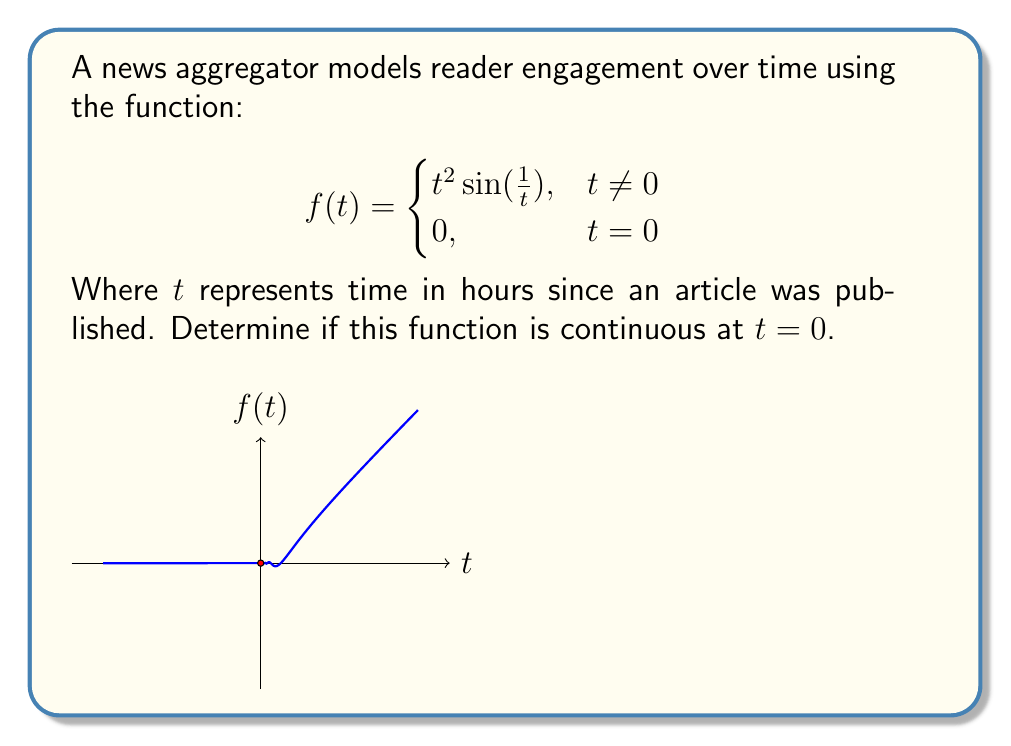Give your solution to this math problem. To determine if the function is continuous at $t = 0$, we need to check three conditions:

1. $f(0)$ exists
2. $\lim_{t \to 0} f(t)$ exists
3. $\lim_{t \to 0} f(t) = f(0)$

Step 1: Check if $f(0)$ exists
From the definition, we see that $f(0) = 0$, so this condition is satisfied.

Step 2: Evaluate $\lim_{t \to 0} f(t)$
We need to evaluate $\lim_{t \to 0} t^2 \sin(\frac{1}{t})$

Let's use the squeeze theorem. We know that $-1 \leq \sin(\frac{1}{t}) \leq 1$ for all $t \neq 0$.
Multiplying by $t^2$ (which is non-negative for $t$ close to 0):

$$-t^2 \leq t^2 \sin(\frac{1}{t}) \leq t^2$$

Taking the limit as $t \to 0$:

$$\lim_{t \to 0} -t^2 \leq \lim_{t \to 0} t^2 \sin(\frac{1}{t}) \leq \lim_{t \to 0} t^2$$

$$0 \leq \lim_{t \to 0} t^2 \sin(\frac{1}{t}) \leq 0$$

By the squeeze theorem, $\lim_{t \to 0} t^2 \sin(\frac{1}{t}) = 0$

Step 3: Compare $\lim_{t \to 0} f(t)$ and $f(0)$
We found that $\lim_{t \to 0} f(t) = 0$ and $f(0) = 0$

Since all three conditions are satisfied, the function is continuous at $t = 0$.
Answer: The function is continuous at $t = 0$. 